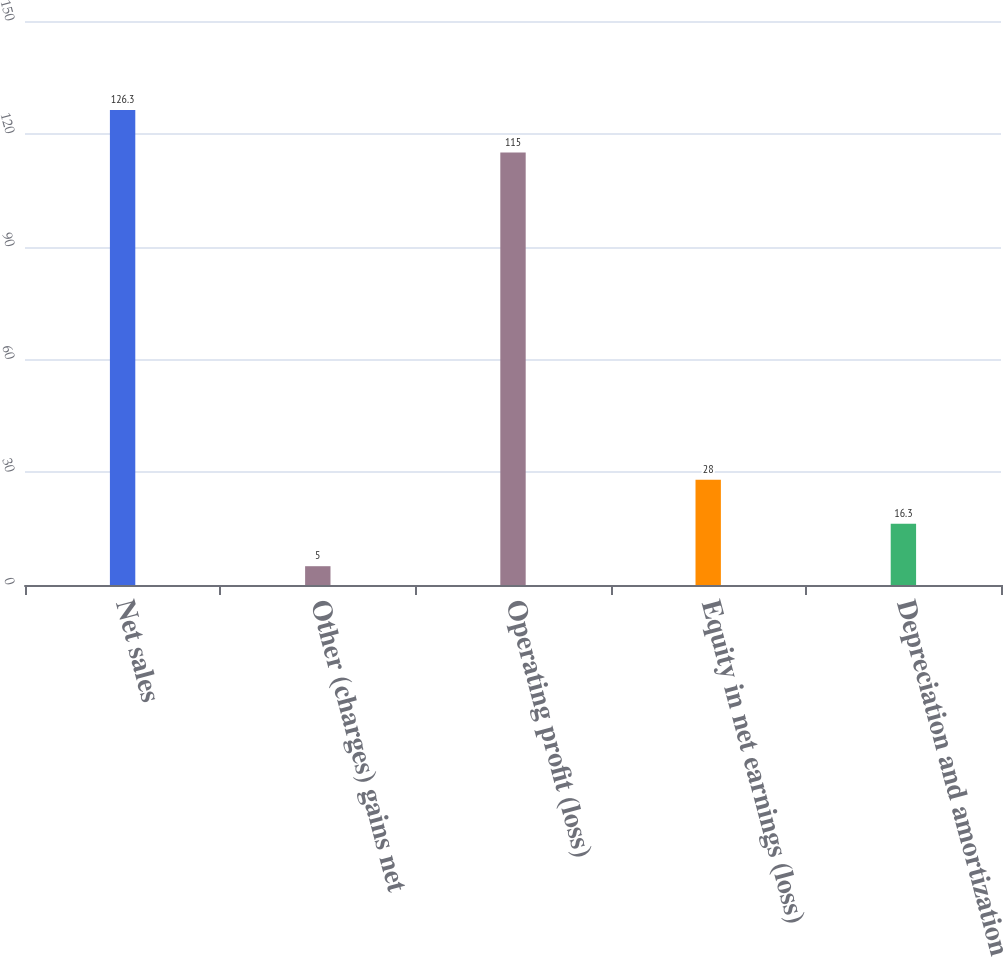Convert chart. <chart><loc_0><loc_0><loc_500><loc_500><bar_chart><fcel>Net sales<fcel>Other (charges) gains net<fcel>Operating profit (loss)<fcel>Equity in net earnings (loss)<fcel>Depreciation and amortization<nl><fcel>126.3<fcel>5<fcel>115<fcel>28<fcel>16.3<nl></chart> 